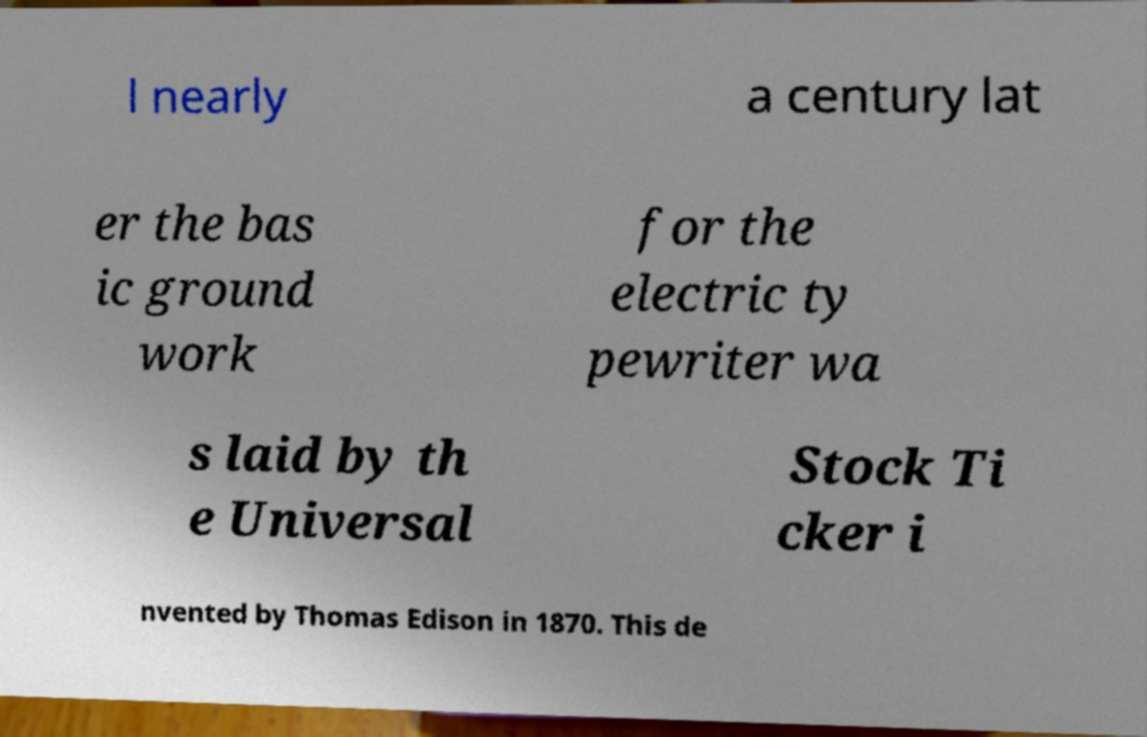Can you accurately transcribe the text from the provided image for me? l nearly a century lat er the bas ic ground work for the electric ty pewriter wa s laid by th e Universal Stock Ti cker i nvented by Thomas Edison in 1870. This de 